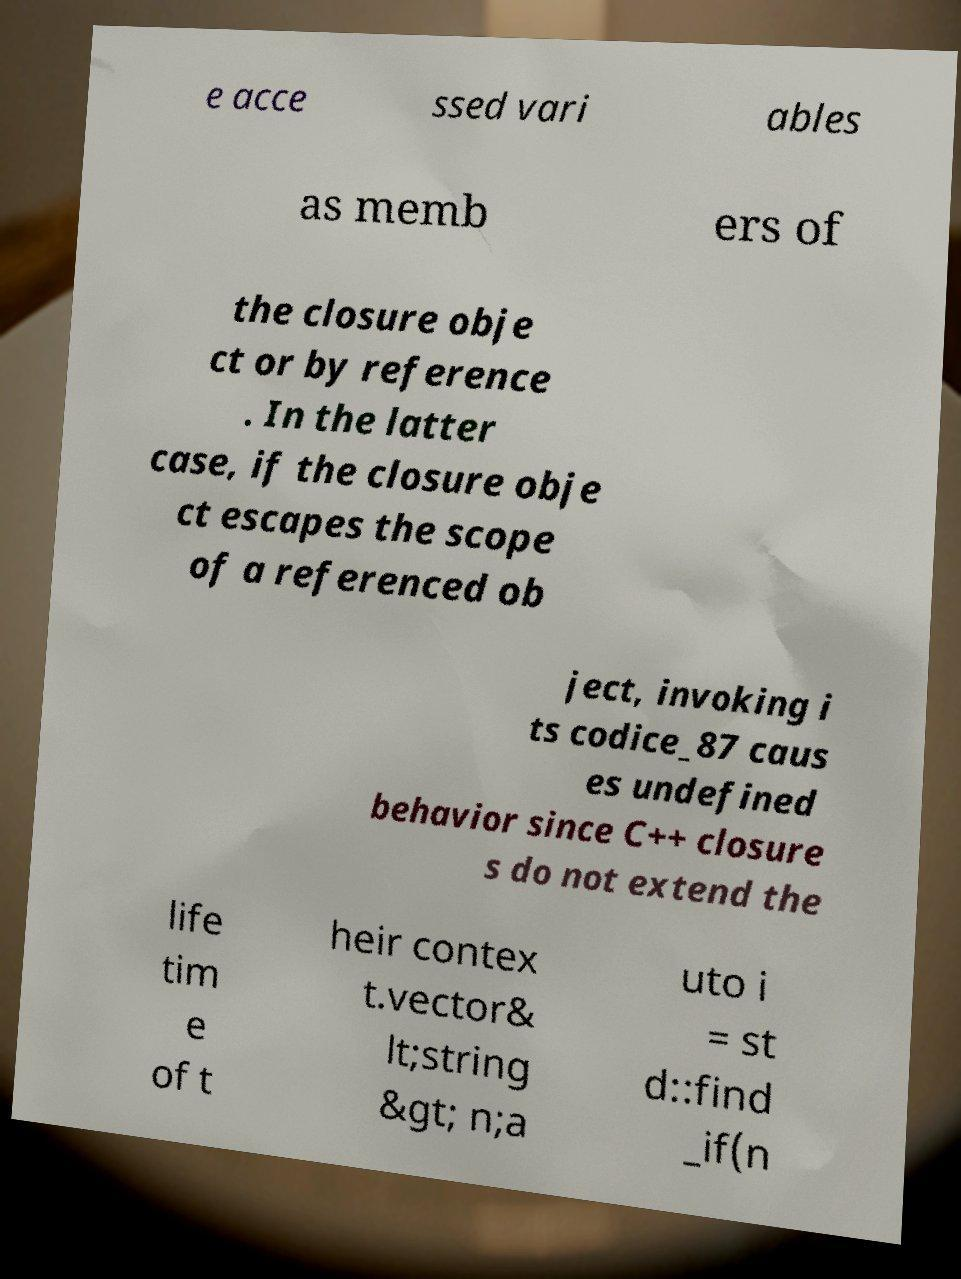Can you read and provide the text displayed in the image?This photo seems to have some interesting text. Can you extract and type it out for me? e acce ssed vari ables as memb ers of the closure obje ct or by reference . In the latter case, if the closure obje ct escapes the scope of a referenced ob ject, invoking i ts codice_87 caus es undefined behavior since C++ closure s do not extend the life tim e of t heir contex t.vector& lt;string &gt; n;a uto i = st d::find _if(n 